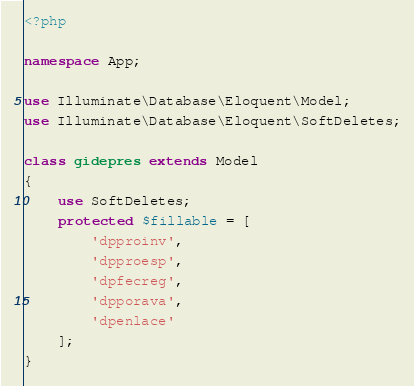Convert code to text. <code><loc_0><loc_0><loc_500><loc_500><_PHP_><?php

namespace App;

use Illuminate\Database\Eloquent\Model;
use Illuminate\Database\Eloquent\SoftDeletes;

class gidepres extends Model
{
    use SoftDeletes;
    protected $fillable = [
        'dpproinv',
        'dpproesp',
        'dpfecreg',
        'dpporava',
        'dpenlace'
    ];
}
</code> 